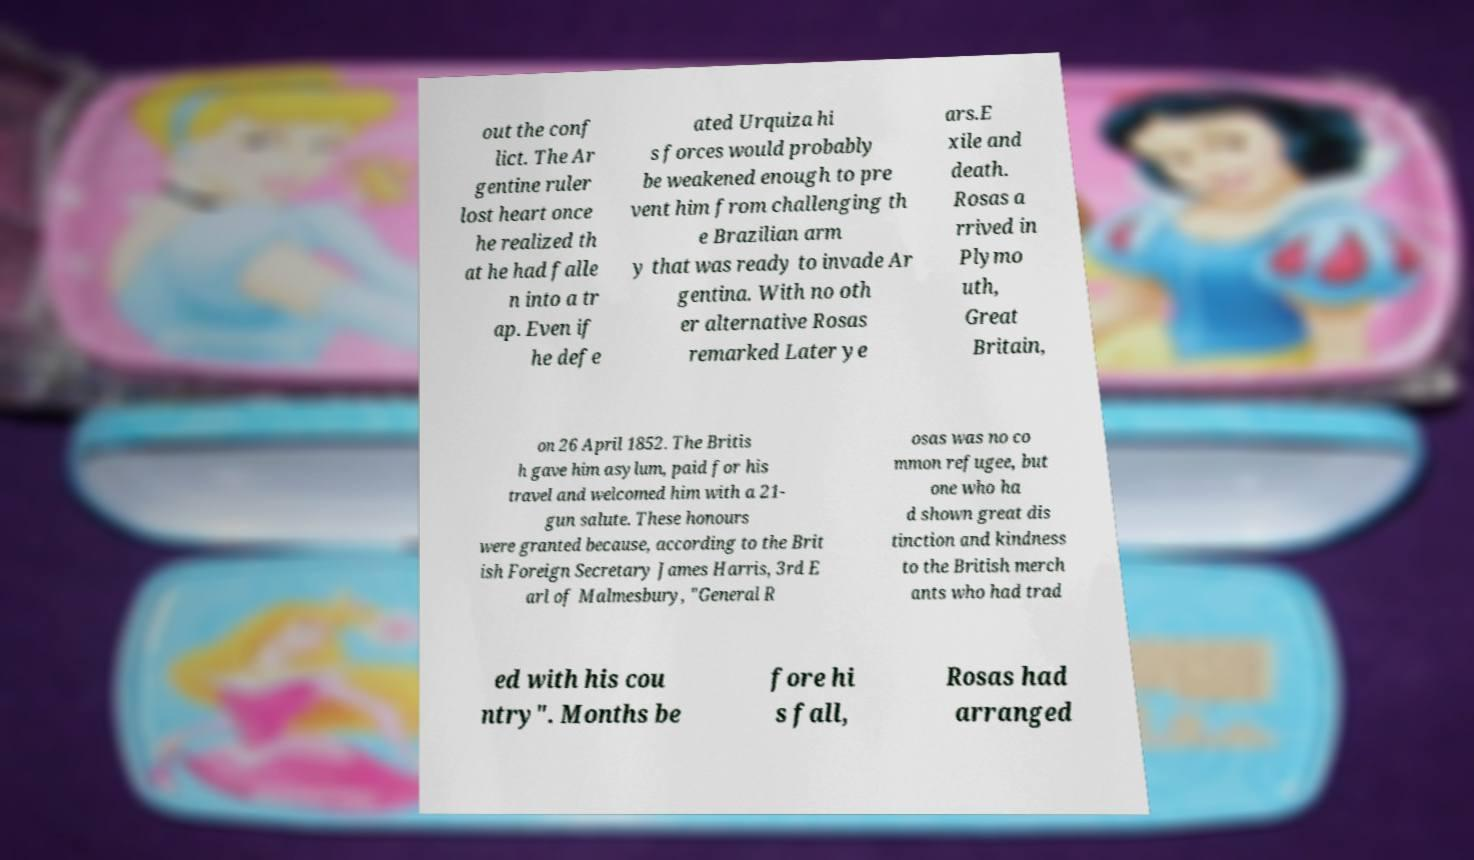Please identify and transcribe the text found in this image. out the conf lict. The Ar gentine ruler lost heart once he realized th at he had falle n into a tr ap. Even if he defe ated Urquiza hi s forces would probably be weakened enough to pre vent him from challenging th e Brazilian arm y that was ready to invade Ar gentina. With no oth er alternative Rosas remarked Later ye ars.E xile and death. Rosas a rrived in Plymo uth, Great Britain, on 26 April 1852. The Britis h gave him asylum, paid for his travel and welcomed him with a 21- gun salute. These honours were granted because, according to the Brit ish Foreign Secretary James Harris, 3rd E arl of Malmesbury, "General R osas was no co mmon refugee, but one who ha d shown great dis tinction and kindness to the British merch ants who had trad ed with his cou ntry". Months be fore hi s fall, Rosas had arranged 